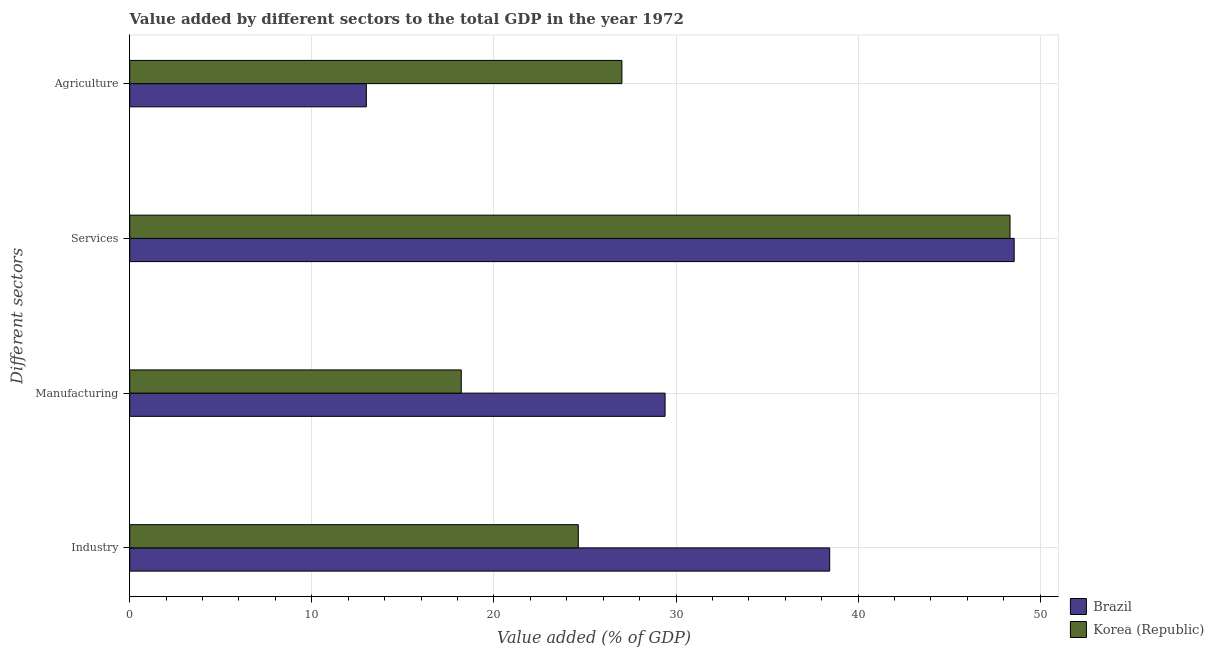How many groups of bars are there?
Offer a very short reply. 4. What is the label of the 2nd group of bars from the top?
Provide a succinct answer. Services. What is the value added by agricultural sector in Korea (Republic)?
Ensure brevity in your answer.  27.03. Across all countries, what is the maximum value added by agricultural sector?
Keep it short and to the point. 27.03. Across all countries, what is the minimum value added by services sector?
Offer a very short reply. 48.34. In which country was the value added by manufacturing sector maximum?
Give a very brief answer. Brazil. In which country was the value added by manufacturing sector minimum?
Provide a succinct answer. Korea (Republic). What is the total value added by agricultural sector in the graph?
Provide a succinct answer. 40.02. What is the difference between the value added by industrial sector in Brazil and that in Korea (Republic)?
Give a very brief answer. 13.8. What is the difference between the value added by services sector in Korea (Republic) and the value added by industrial sector in Brazil?
Provide a succinct answer. 9.9. What is the average value added by manufacturing sector per country?
Provide a short and direct response. 23.8. What is the difference between the value added by agricultural sector and value added by industrial sector in Korea (Republic)?
Offer a terse response. 2.39. What is the ratio of the value added by manufacturing sector in Brazil to that in Korea (Republic)?
Your answer should be compact. 1.61. What is the difference between the highest and the second highest value added by manufacturing sector?
Keep it short and to the point. 11.19. What is the difference between the highest and the lowest value added by agricultural sector?
Keep it short and to the point. 14.03. What does the 1st bar from the top in Industry represents?
Keep it short and to the point. Korea (Republic). What does the 2nd bar from the bottom in Agriculture represents?
Your answer should be compact. Korea (Republic). Is it the case that in every country, the sum of the value added by industrial sector and value added by manufacturing sector is greater than the value added by services sector?
Your answer should be compact. No. Does the graph contain any zero values?
Make the answer very short. No. Does the graph contain grids?
Ensure brevity in your answer.  Yes. Where does the legend appear in the graph?
Make the answer very short. Bottom right. How many legend labels are there?
Your response must be concise. 2. How are the legend labels stacked?
Give a very brief answer. Vertical. What is the title of the graph?
Provide a succinct answer. Value added by different sectors to the total GDP in the year 1972. What is the label or title of the X-axis?
Give a very brief answer. Value added (% of GDP). What is the label or title of the Y-axis?
Keep it short and to the point. Different sectors. What is the Value added (% of GDP) of Brazil in Industry?
Your answer should be very brief. 38.44. What is the Value added (% of GDP) of Korea (Republic) in Industry?
Offer a very short reply. 24.63. What is the Value added (% of GDP) in Brazil in Manufacturing?
Provide a succinct answer. 29.4. What is the Value added (% of GDP) in Korea (Republic) in Manufacturing?
Provide a succinct answer. 18.21. What is the Value added (% of GDP) of Brazil in Services?
Your response must be concise. 48.57. What is the Value added (% of GDP) in Korea (Republic) in Services?
Your answer should be very brief. 48.34. What is the Value added (% of GDP) of Brazil in Agriculture?
Provide a short and direct response. 12.99. What is the Value added (% of GDP) in Korea (Republic) in Agriculture?
Provide a succinct answer. 27.03. Across all Different sectors, what is the maximum Value added (% of GDP) in Brazil?
Your answer should be very brief. 48.57. Across all Different sectors, what is the maximum Value added (% of GDP) of Korea (Republic)?
Offer a terse response. 48.34. Across all Different sectors, what is the minimum Value added (% of GDP) in Brazil?
Keep it short and to the point. 12.99. Across all Different sectors, what is the minimum Value added (% of GDP) in Korea (Republic)?
Offer a terse response. 18.21. What is the total Value added (% of GDP) of Brazil in the graph?
Provide a short and direct response. 129.4. What is the total Value added (% of GDP) in Korea (Republic) in the graph?
Give a very brief answer. 118.21. What is the difference between the Value added (% of GDP) in Brazil in Industry and that in Manufacturing?
Make the answer very short. 9.04. What is the difference between the Value added (% of GDP) in Korea (Republic) in Industry and that in Manufacturing?
Give a very brief answer. 6.43. What is the difference between the Value added (% of GDP) in Brazil in Industry and that in Services?
Ensure brevity in your answer.  -10.13. What is the difference between the Value added (% of GDP) of Korea (Republic) in Industry and that in Services?
Keep it short and to the point. -23.71. What is the difference between the Value added (% of GDP) of Brazil in Industry and that in Agriculture?
Keep it short and to the point. 25.44. What is the difference between the Value added (% of GDP) of Korea (Republic) in Industry and that in Agriculture?
Give a very brief answer. -2.39. What is the difference between the Value added (% of GDP) in Brazil in Manufacturing and that in Services?
Keep it short and to the point. -19.17. What is the difference between the Value added (% of GDP) of Korea (Republic) in Manufacturing and that in Services?
Provide a succinct answer. -30.13. What is the difference between the Value added (% of GDP) of Brazil in Manufacturing and that in Agriculture?
Offer a very short reply. 16.4. What is the difference between the Value added (% of GDP) of Korea (Republic) in Manufacturing and that in Agriculture?
Your answer should be compact. -8.82. What is the difference between the Value added (% of GDP) of Brazil in Services and that in Agriculture?
Make the answer very short. 35.57. What is the difference between the Value added (% of GDP) in Korea (Republic) in Services and that in Agriculture?
Offer a very short reply. 21.31. What is the difference between the Value added (% of GDP) in Brazil in Industry and the Value added (% of GDP) in Korea (Republic) in Manufacturing?
Ensure brevity in your answer.  20.23. What is the difference between the Value added (% of GDP) of Brazil in Industry and the Value added (% of GDP) of Korea (Republic) in Services?
Make the answer very short. -9.9. What is the difference between the Value added (% of GDP) of Brazil in Industry and the Value added (% of GDP) of Korea (Republic) in Agriculture?
Ensure brevity in your answer.  11.41. What is the difference between the Value added (% of GDP) of Brazil in Manufacturing and the Value added (% of GDP) of Korea (Republic) in Services?
Offer a terse response. -18.94. What is the difference between the Value added (% of GDP) in Brazil in Manufacturing and the Value added (% of GDP) in Korea (Republic) in Agriculture?
Make the answer very short. 2.37. What is the difference between the Value added (% of GDP) in Brazil in Services and the Value added (% of GDP) in Korea (Republic) in Agriculture?
Your response must be concise. 21.54. What is the average Value added (% of GDP) in Brazil per Different sectors?
Provide a short and direct response. 32.35. What is the average Value added (% of GDP) of Korea (Republic) per Different sectors?
Keep it short and to the point. 29.55. What is the difference between the Value added (% of GDP) of Brazil and Value added (% of GDP) of Korea (Republic) in Industry?
Your answer should be compact. 13.8. What is the difference between the Value added (% of GDP) of Brazil and Value added (% of GDP) of Korea (Republic) in Manufacturing?
Offer a terse response. 11.19. What is the difference between the Value added (% of GDP) of Brazil and Value added (% of GDP) of Korea (Republic) in Services?
Provide a short and direct response. 0.23. What is the difference between the Value added (% of GDP) in Brazil and Value added (% of GDP) in Korea (Republic) in Agriculture?
Your answer should be compact. -14.03. What is the ratio of the Value added (% of GDP) in Brazil in Industry to that in Manufacturing?
Provide a succinct answer. 1.31. What is the ratio of the Value added (% of GDP) in Korea (Republic) in Industry to that in Manufacturing?
Your answer should be very brief. 1.35. What is the ratio of the Value added (% of GDP) of Brazil in Industry to that in Services?
Offer a terse response. 0.79. What is the ratio of the Value added (% of GDP) in Korea (Republic) in Industry to that in Services?
Give a very brief answer. 0.51. What is the ratio of the Value added (% of GDP) in Brazil in Industry to that in Agriculture?
Ensure brevity in your answer.  2.96. What is the ratio of the Value added (% of GDP) of Korea (Republic) in Industry to that in Agriculture?
Your response must be concise. 0.91. What is the ratio of the Value added (% of GDP) of Brazil in Manufacturing to that in Services?
Keep it short and to the point. 0.61. What is the ratio of the Value added (% of GDP) of Korea (Republic) in Manufacturing to that in Services?
Make the answer very short. 0.38. What is the ratio of the Value added (% of GDP) in Brazil in Manufacturing to that in Agriculture?
Your response must be concise. 2.26. What is the ratio of the Value added (% of GDP) of Korea (Republic) in Manufacturing to that in Agriculture?
Your response must be concise. 0.67. What is the ratio of the Value added (% of GDP) of Brazil in Services to that in Agriculture?
Keep it short and to the point. 3.74. What is the ratio of the Value added (% of GDP) in Korea (Republic) in Services to that in Agriculture?
Your answer should be very brief. 1.79. What is the difference between the highest and the second highest Value added (% of GDP) in Brazil?
Offer a terse response. 10.13. What is the difference between the highest and the second highest Value added (% of GDP) in Korea (Republic)?
Ensure brevity in your answer.  21.31. What is the difference between the highest and the lowest Value added (% of GDP) in Brazil?
Your response must be concise. 35.57. What is the difference between the highest and the lowest Value added (% of GDP) of Korea (Republic)?
Make the answer very short. 30.13. 